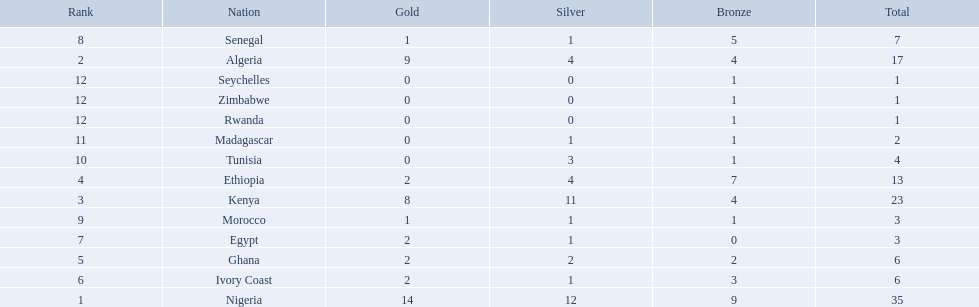What nations competed at the 1989 african championships in athletics? Nigeria, Algeria, Kenya, Ethiopia, Ghana, Ivory Coast, Egypt, Senegal, Morocco, Tunisia, Madagascar, Rwanda, Zimbabwe, Seychelles. What nations earned bronze medals? Nigeria, Algeria, Kenya, Ethiopia, Ghana, Ivory Coast, Senegal, Morocco, Tunisia, Madagascar, Rwanda, Zimbabwe, Seychelles. What nation did not earn a bronze medal? Egypt. 